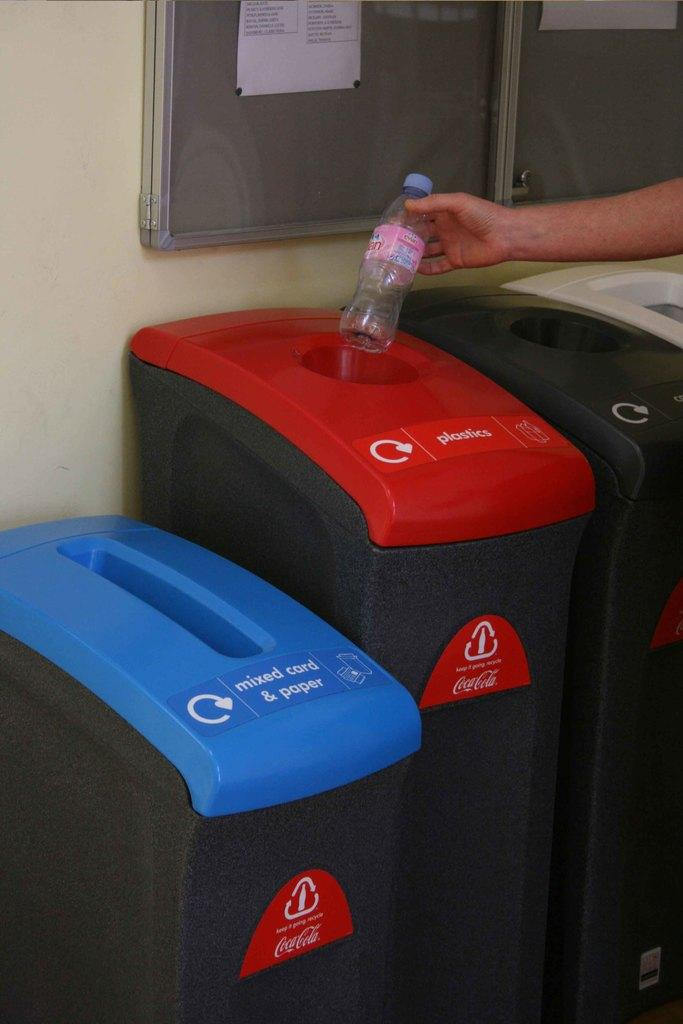What is the main subject of the image? There is a person in the image. What action is the person performing? The person is throwing a bottle. What is the intended destination of the thrown bottle? The bottle is being thrown into a recycle bin. What type of comfort can be seen in the image? There is no visible comfort in the image; it features a person throwing a bottle into a recycle bin. What type of lamp is present in the image? There is no lamp present in the image. 